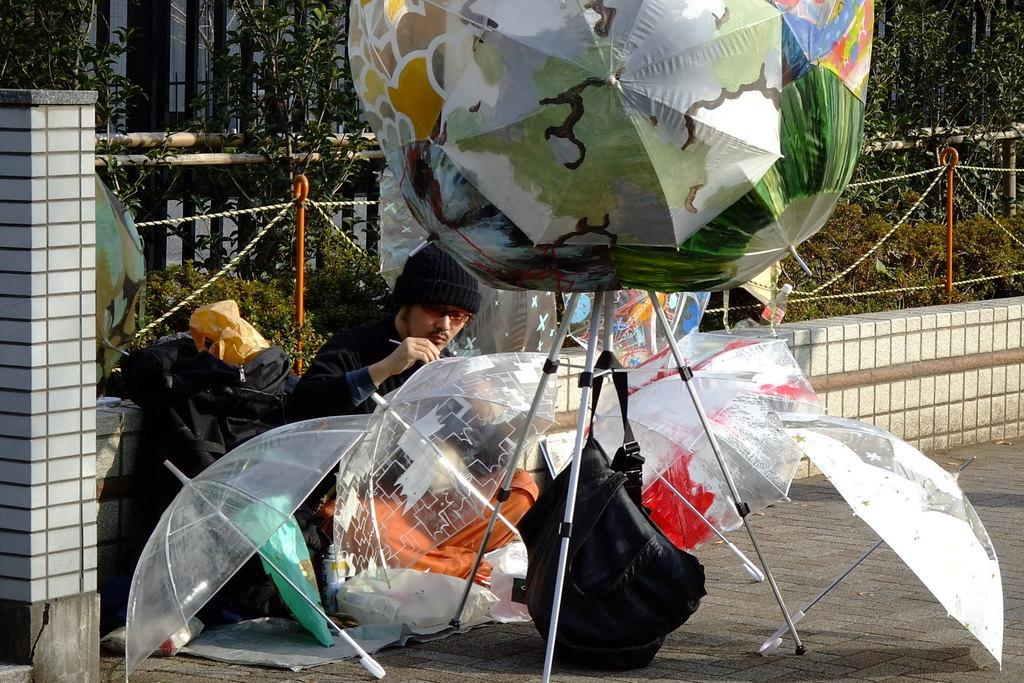What is the main subject in the image? There is a person in the image. What objects are present in the image that might be used for protection from the elements? There are umbrellas in the image. What item is visible that might be used for carrying personal belongings? There is a bag in the image. What type of structure can be seen in the image? There is a stand in the image. What architectural feature is present in the image? There is a pillar in the image. What type of barrier or boundary is visible in the image? There is a wall in the image. What objects are present in the image that might be used for support or construction? There are rods in the image. What objects are present in the image that might be used for tying or securing? There are ropes in the image. What type of natural elements can be seen in the background of the image? There are plants and trees in the background of the image. What type of letter is being delivered to the person in the image? There is no letter present in the image. 